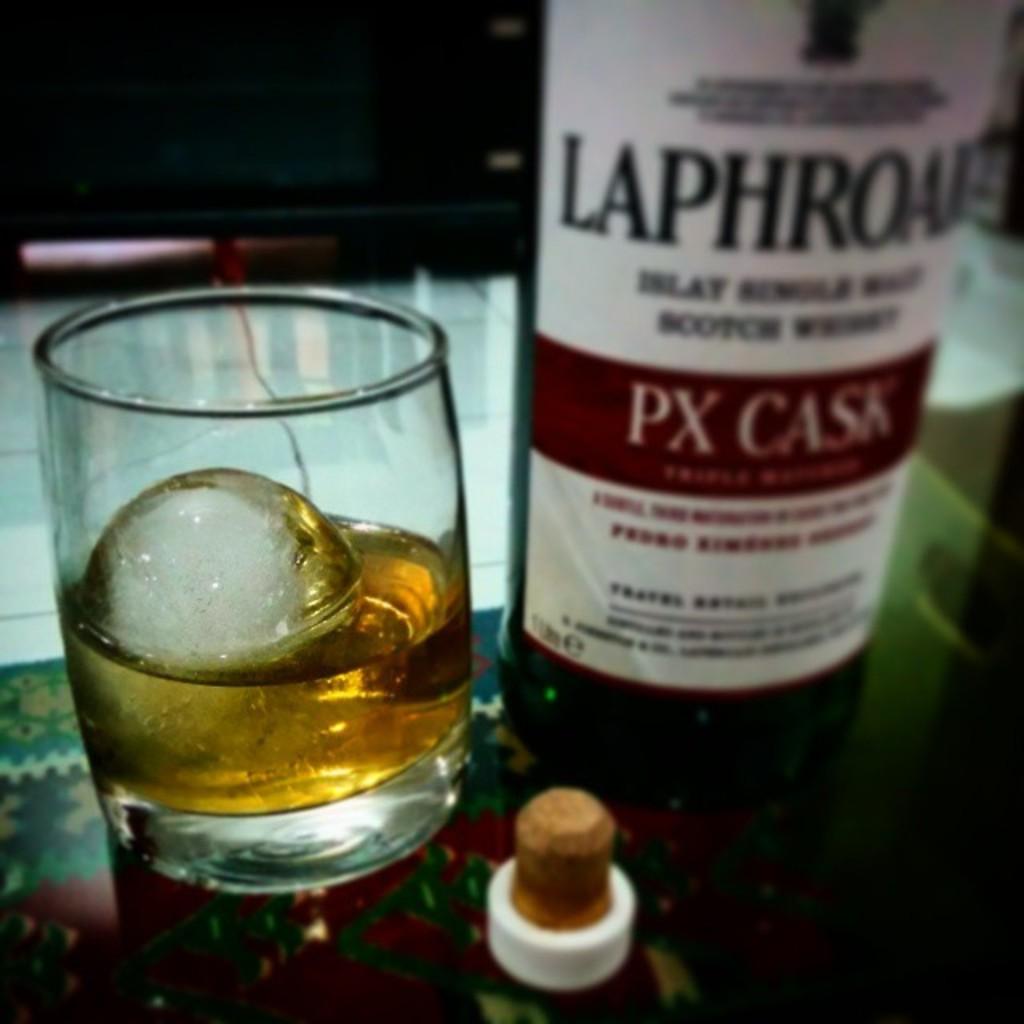What is the brand of this drink?
Keep it short and to the point. Px cask. Laphroaf px cask?
Give a very brief answer. Yes. 